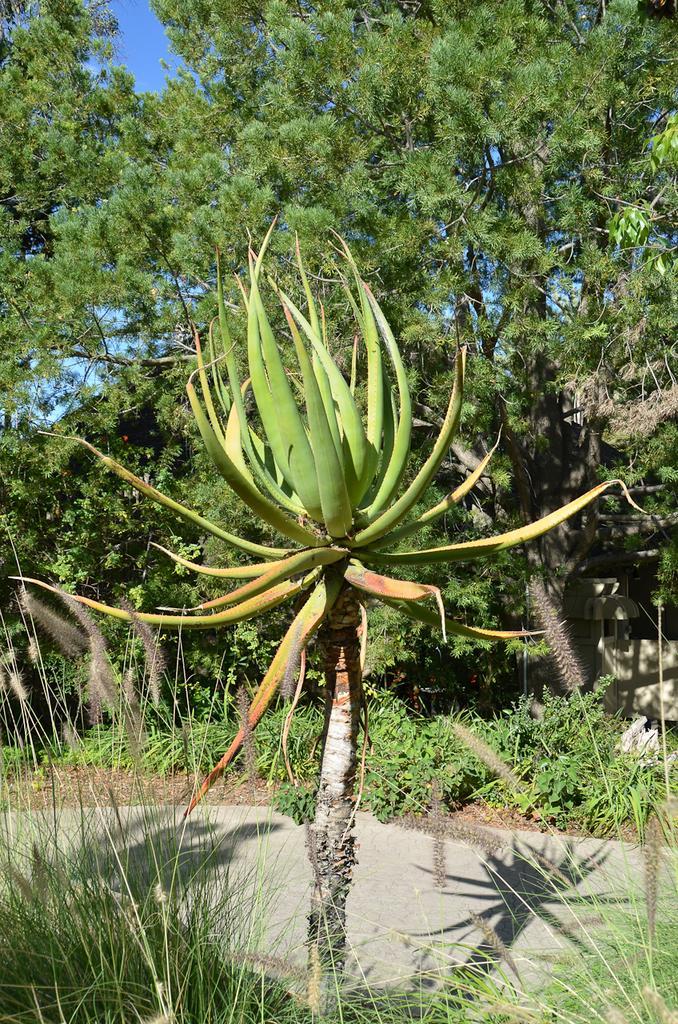How would you summarize this image in a sentence or two? In this image we can see a plant. In the background, we can see a group of trees and the sky. 